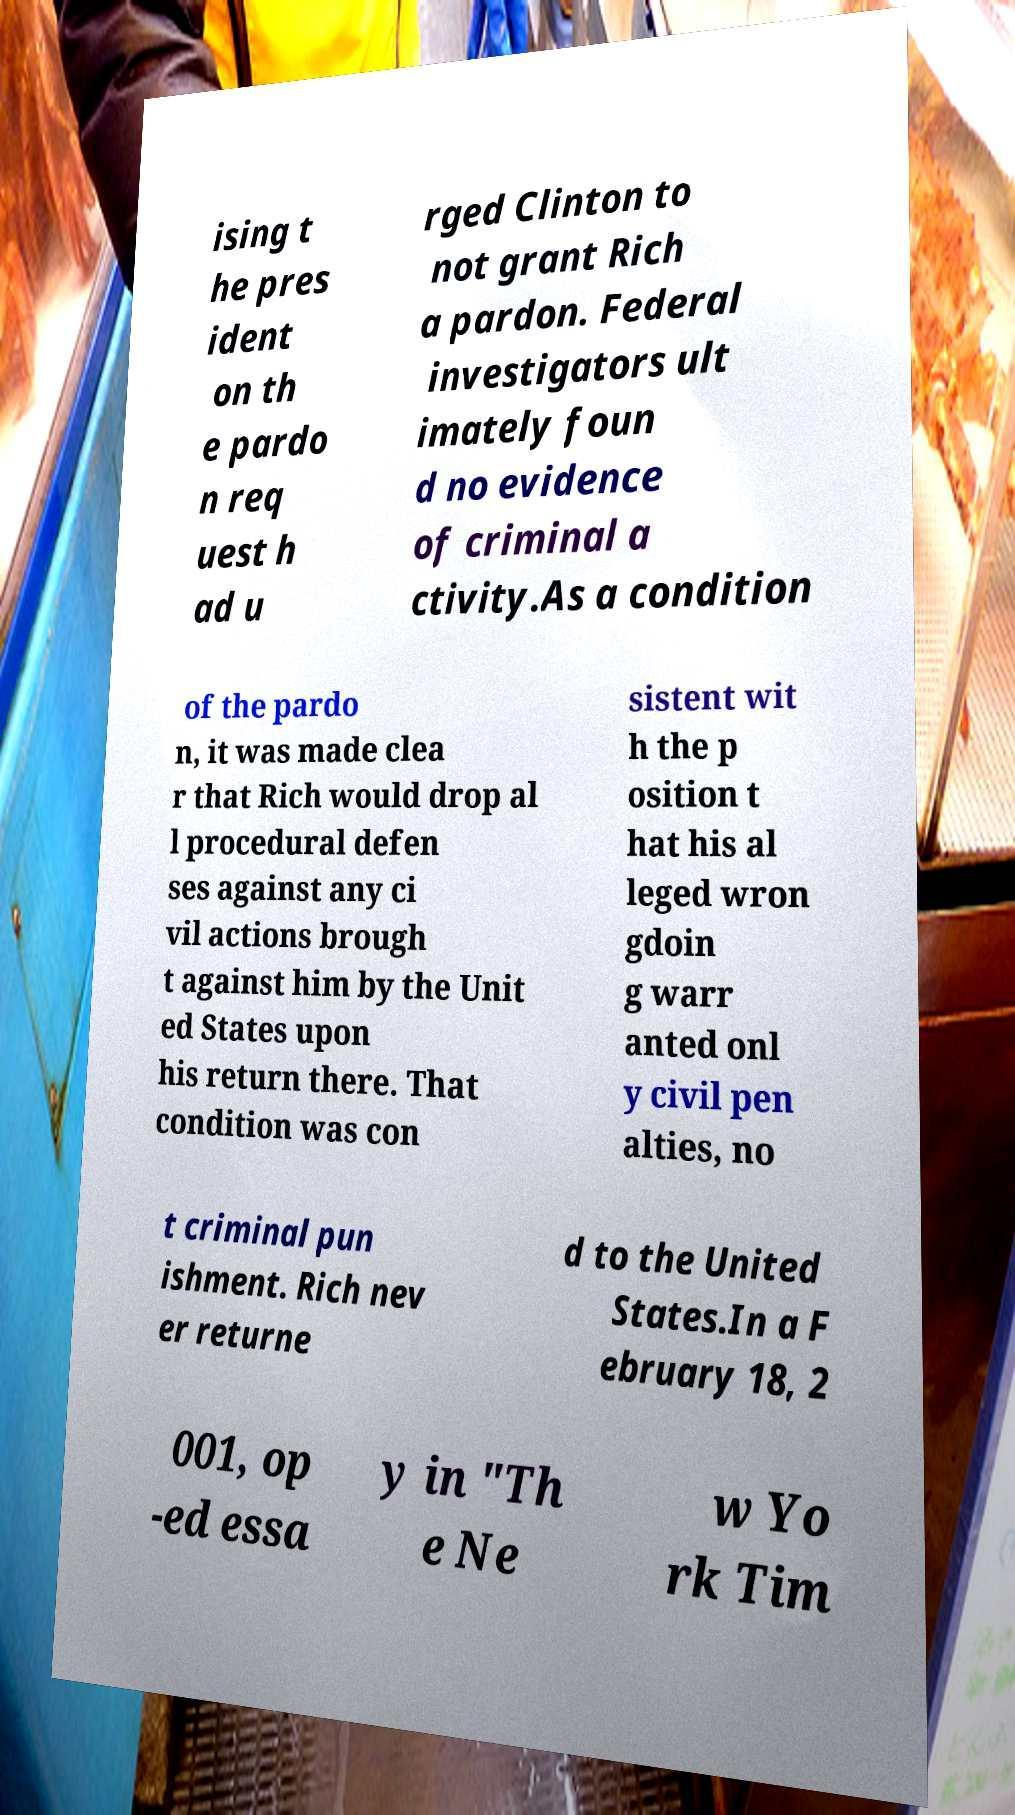Please read and relay the text visible in this image. What does it say? ising t he pres ident on th e pardo n req uest h ad u rged Clinton to not grant Rich a pardon. Federal investigators ult imately foun d no evidence of criminal a ctivity.As a condition of the pardo n, it was made clea r that Rich would drop al l procedural defen ses against any ci vil actions brough t against him by the Unit ed States upon his return there. That condition was con sistent wit h the p osition t hat his al leged wron gdoin g warr anted onl y civil pen alties, no t criminal pun ishment. Rich nev er returne d to the United States.In a F ebruary 18, 2 001, op -ed essa y in "Th e Ne w Yo rk Tim 